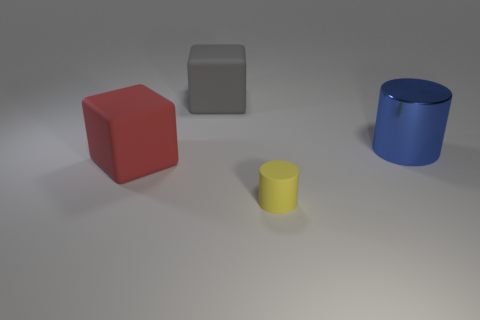Is there anything else that has the same size as the yellow matte cylinder?
Give a very brief answer. No. Are there any other things that have the same material as the big blue object?
Provide a succinct answer. No. What number of shiny things are either big cubes or big yellow cubes?
Ensure brevity in your answer.  0. Is the number of big gray shiny cylinders less than the number of big blue metallic things?
Provide a succinct answer. Yes. There is a yellow rubber cylinder; is its size the same as the rubber block to the right of the big red object?
Ensure brevity in your answer.  No. Is there anything else that is the same shape as the gray matte thing?
Provide a short and direct response. Yes. The yellow rubber object is what size?
Ensure brevity in your answer.  Small. Is the number of large rubber things to the right of the red object less than the number of large green spheres?
Provide a short and direct response. No. Do the blue metal cylinder and the yellow thing have the same size?
Offer a very short reply. No. There is a small cylinder that is the same material as the red thing; what is its color?
Provide a short and direct response. Yellow. 